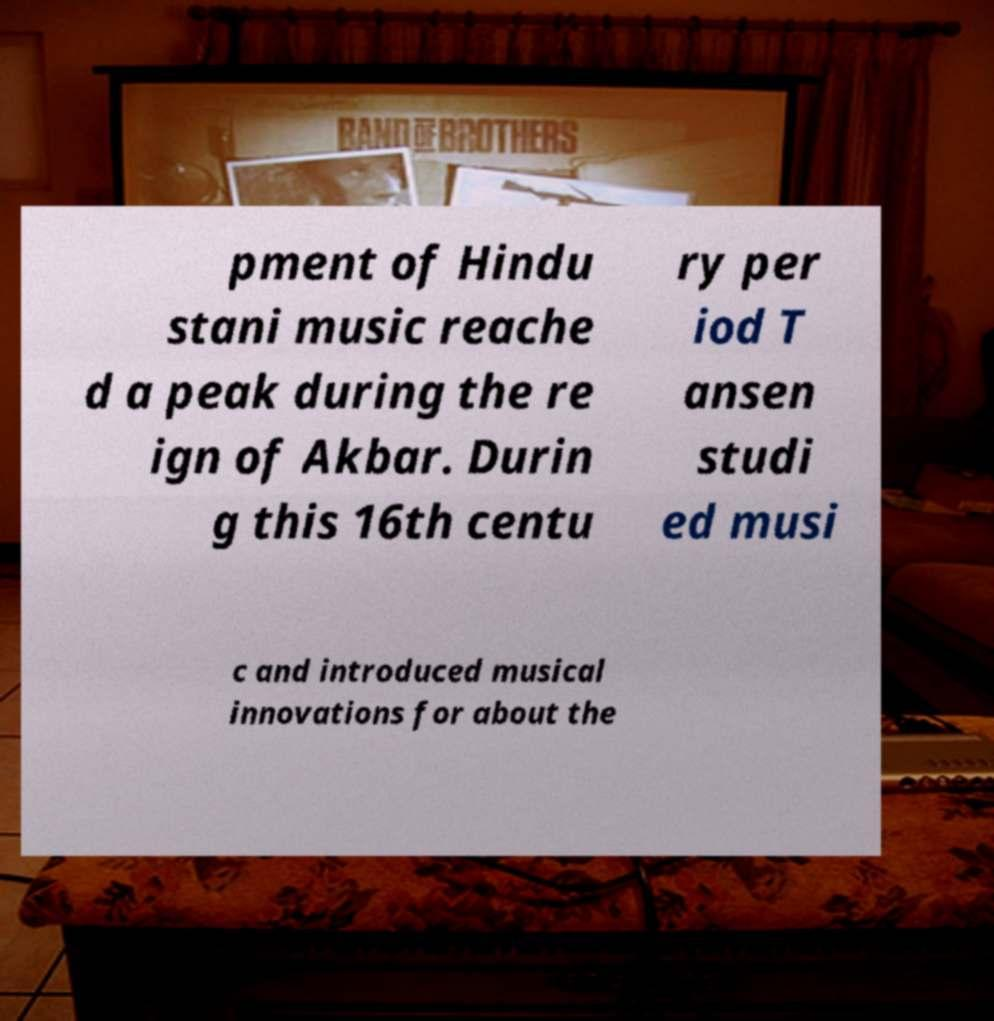Please read and relay the text visible in this image. What does it say? pment of Hindu stani music reache d a peak during the re ign of Akbar. Durin g this 16th centu ry per iod T ansen studi ed musi c and introduced musical innovations for about the 